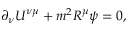<formula> <loc_0><loc_0><loc_500><loc_500>\partial _ { \nu } U ^ { \nu \mu } + m ^ { 2 } R ^ { \mu } \psi = 0 ,</formula> 